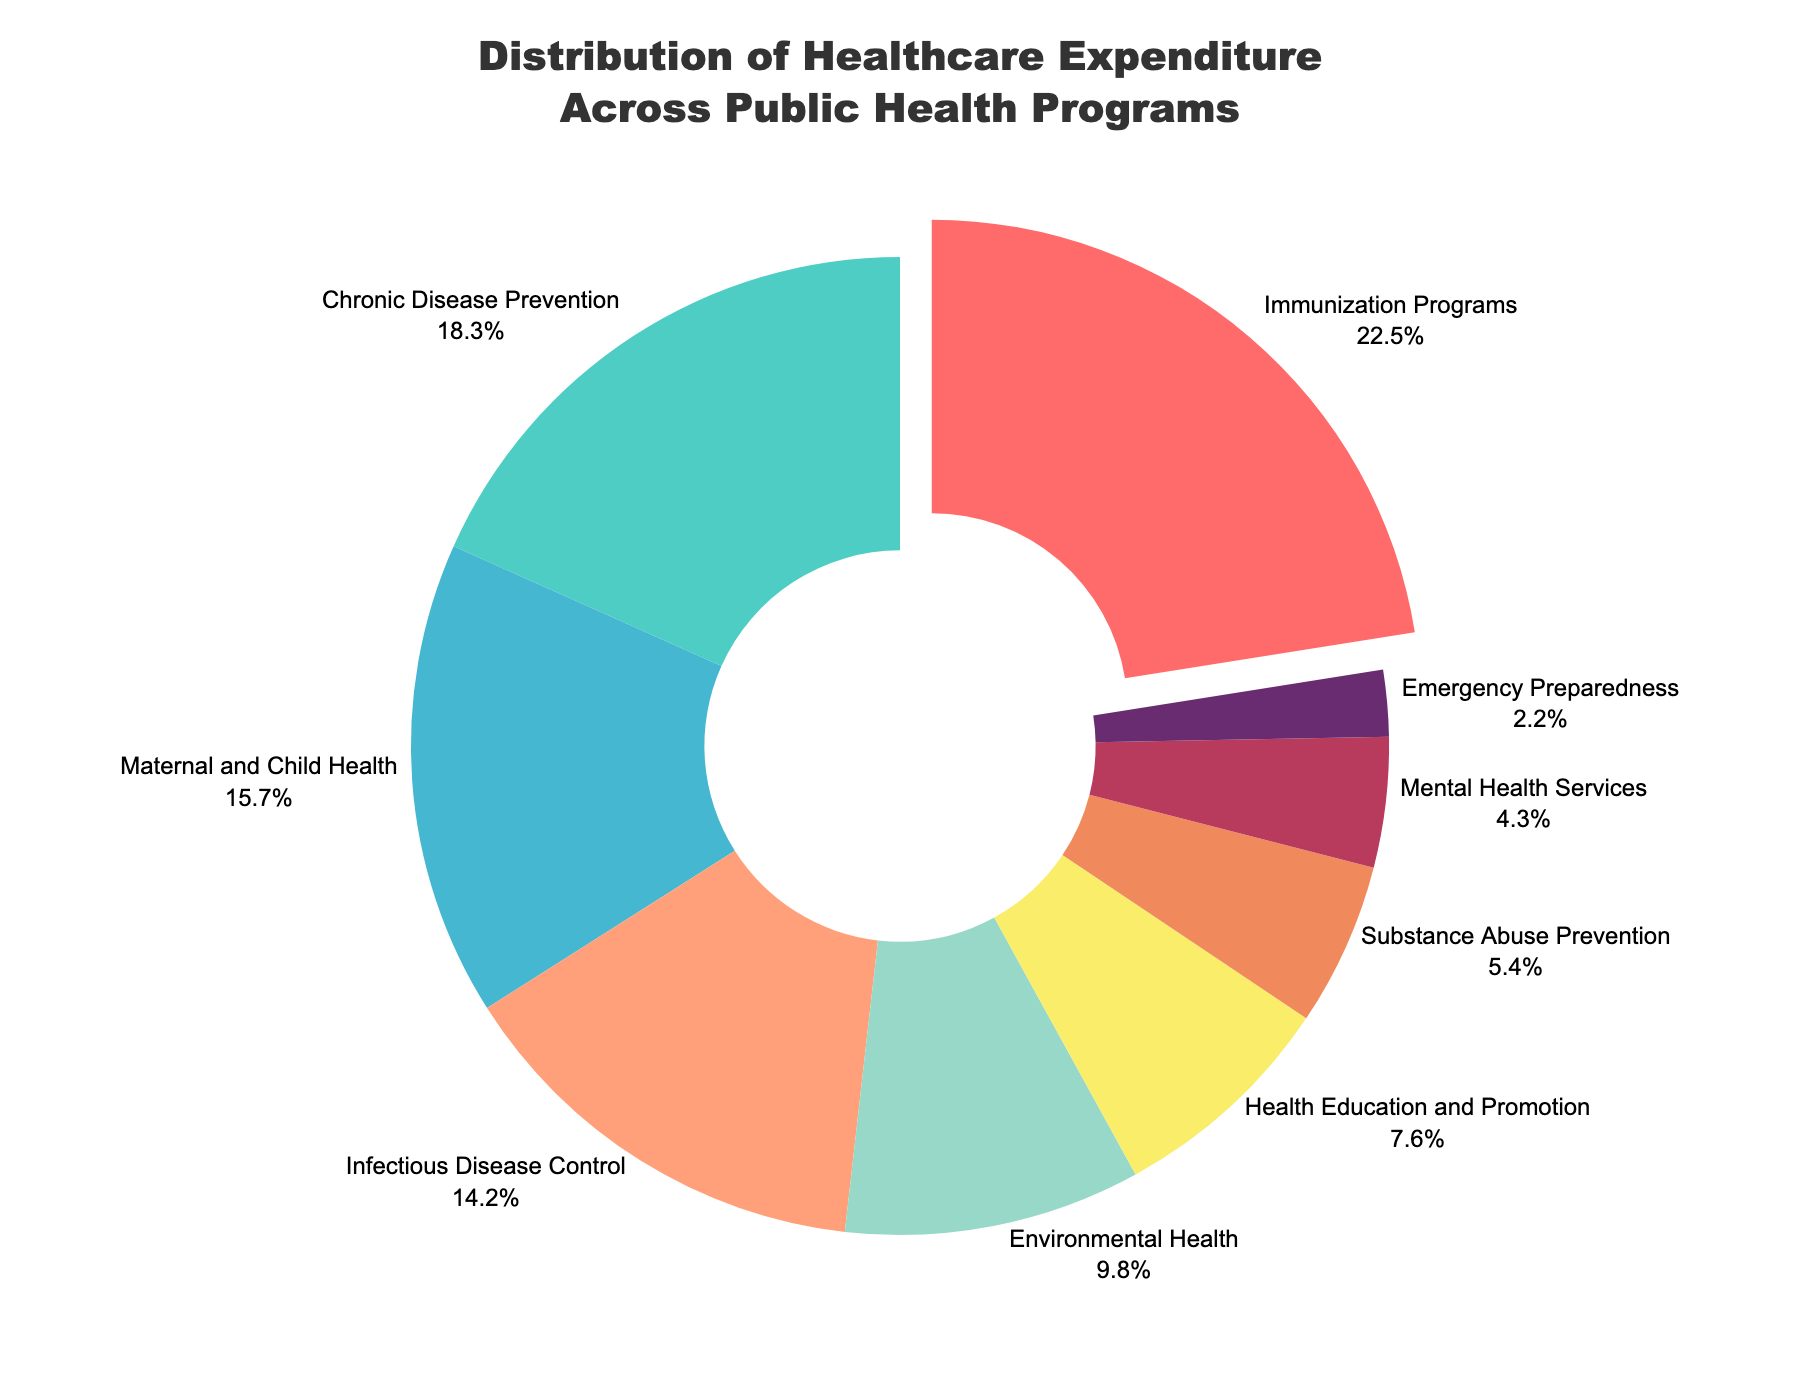What is the percentage of expenditure allocated to Immunization Programs? The slice that represents Immunization Programs is labeled with both the program name and the percentage. By looking at the figure, we can find the label that says "Immunization Programs" and refer to the associated percentage.
Answer: 22.5% What is the combined expenditure percentage of Infectious Disease Control and Environmental Health? Find the percentages associated with Infectious Disease Control (14.2%) and Environmental Health (9.8%), then add them together: 14.2 + 9.8.
Answer: 24% Which program has the smallest share of the healthcare expenditure? By comparing the sizes of the slices, the smallest slice can be identified. The label on the smallest slice indicates the program.
Answer: Emergency Preparedness Does Health Education and Promotion receive more or less funding than Substance Abuse Prevention? Compare the percentages: Health Education and Promotion has 7.6%, while Substance Abuse Prevention has 5.4%.
Answer: More By how much does the expenditure on Chronic Disease Prevention exceed the expenditure on Maternal and Child Health? Find the expenditures for Chronic Disease Prevention (18.3%) and Maternal and Child Health (15.7%), then subtract the latter from the former: 18.3 - 15.7.
Answer: 2.6% Which program is pulling away from the center of the chart, indicating it has the highest percentage expenditure? Identify the slice that is pulled away from the center. This visual effect is used to highlight the category with the highest value.
Answer: Immunization Programs What is the total expenditure percentage of the top three funded programs? Identify the top three funded programs: Immunization Programs (22.5%), Chronic Disease Prevention (18.3%), and Maternal and Child Health (15.7%). Sum these percentages: 22.5 + 18.3 + 15.7.
Answer: 56.5% What is the color used to represent the Mental Health Services program on the donut chart? Look for the slice labeled "Mental Health Services" and note the color used to fill this slice in the chart.
Answer: Various shades of purple (but you can pick the specific color used in the chart) How does the expenditure percentage for Substance Abuse Prevention compare to that for Mental Health Services? Look at the percentages for both Substance Abuse Prevention (5.4%) and Mental Health Services (4.3%) and compare them.
Answer: Higher for Substance Abuse Prevention What is the combined expenditure percentage of all the programs excluding the top three funded ones? Identify the expenditures for the top three funded programs: Immunization Programs (22.5%), Chronic Disease Prevention (18.3%), and Maternal and Child Health (15.7%) which sum up to 56.5%. Subtract this total from 100%: 100 - 56.5.
Answer: 43.5% 